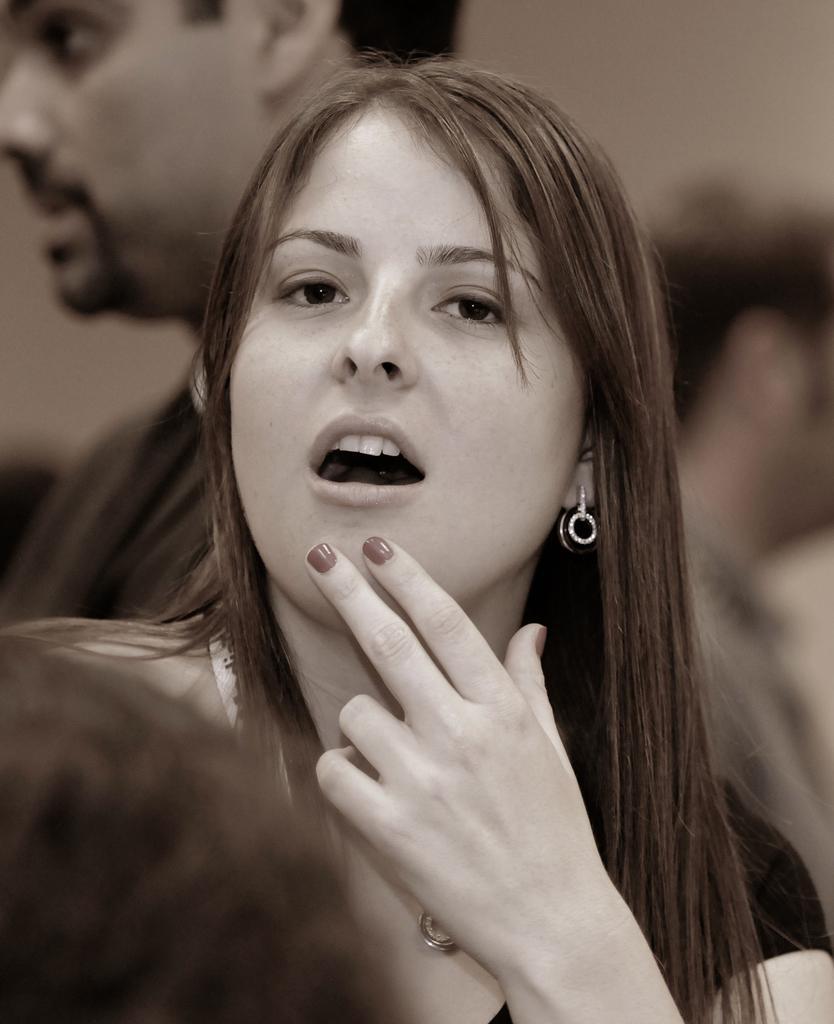Could you give a brief overview of what you see in this image? Here we can see a woman and at the bottom we can see a person head. In the background there are few persons. 